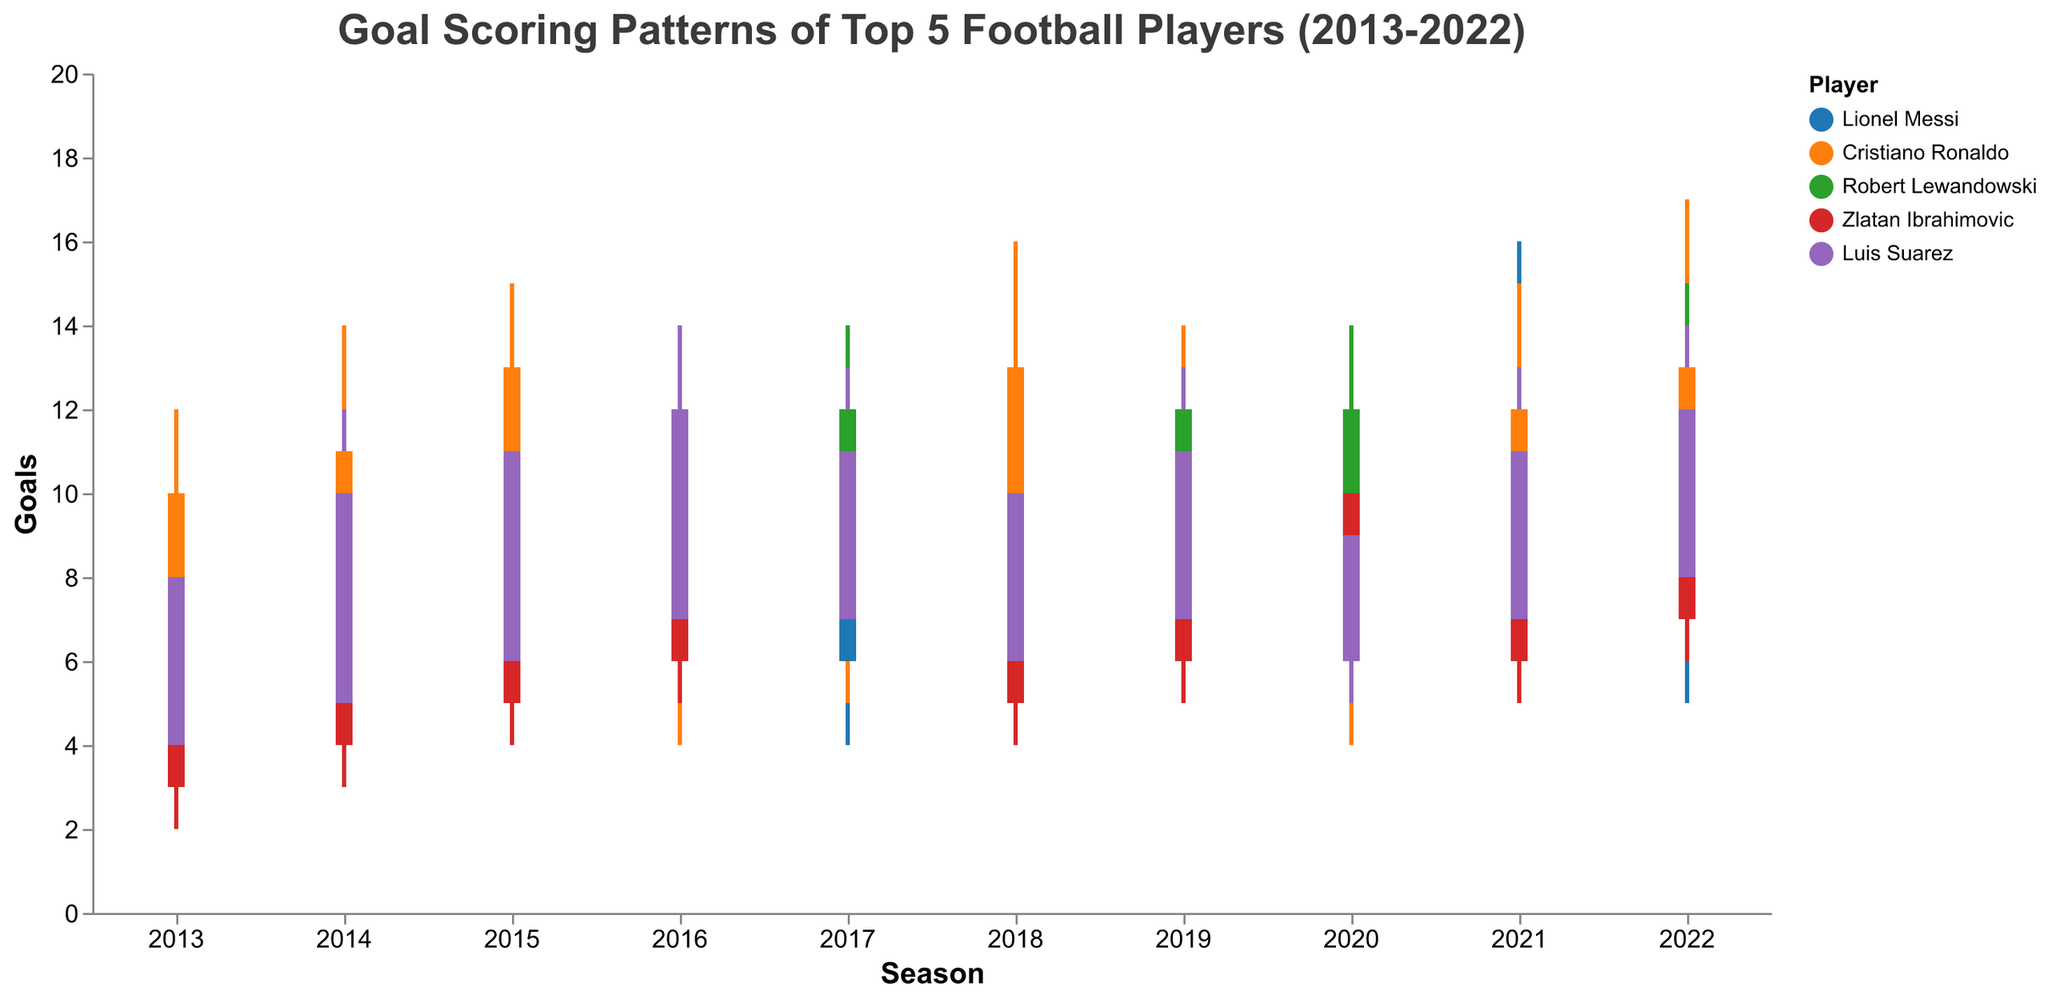Which player had the highest peak in goals across all seasons? To find the player with the highest peak in goals, we look for the highest "High" value across all seasons in the plot. The highest peak is visible at 17 goals, scored by Cristiano Ronaldo in 2022.
Answer: Cristiano Ronaldo How did Lionel Messi's goal trend move between the years 2013 and 2022? To evaluate Messi's goal trend, one should examine his "Open" and "Close" values across the years. His "High" values peaked around 2016 and remained relatively high until 2022, with fluctuations in "Low" and "Open" values.
Answer: Generally upward with fluctuations In which season did Robert Lewandowski show the largest difference between his highest and lowest goal counts? The largest difference between the "High" and "Low" values can be found by examining the spread in each season. In 2022, Lewandowski had a difference of 15 - 7 = 8 goals.
Answer: 2022 Compare the goals scored by Luis Suarez in 2015 and 2016. Which season was more successful in terms of goals? By comparing the "High" and "Close" values in 2015 and 2016, we see that in 2016, Suarez scored higher maximum goals (14 vs. 13) and finished the season stronger (12 vs. 11 goals).
Answer: 2016 Which two players had a similar goal-scoring pattern in 2019, and what were the similarities? Examining the goal-scoring data for 2019, both Lionel Messi and Cristiano Ronaldo had the same low and high values (Messi: 14-7 and Ronaldo: 14-7), but their open and close values were different.
Answer: Lionel Messi and Cristiano Ronaldo Which season did Zlatan Ibrahimovic start with the highest number of goals, and what was his "Open" value? For Zlatan Ibrahimovic, the highest "Open" value, observed when the season started, was in 2017 with 7 goals.
Answer: 2017 Did any player consistently score more than a high of 15 goals in all ten seasons? By evaluating the "High" goal values over the ten seasons, we observe that no player consistently had a high score greater than 15 goals. Cristiano Ronaldo came the closest, with peaks around 16-17 goals in some seasons.
Answer: No How often did Luis Suarez achieve an "Open" value of 7 goals or higher? Observing the "Open" values for Suarez over ten seasons, he achieved a value of 7 or higher in the following seasons: 2016 (7), 2017 (7), 2019 (7), 2021 (7), and 2022 (8). Count these values to find that he achieved this 5 times.
Answer: 5 times 